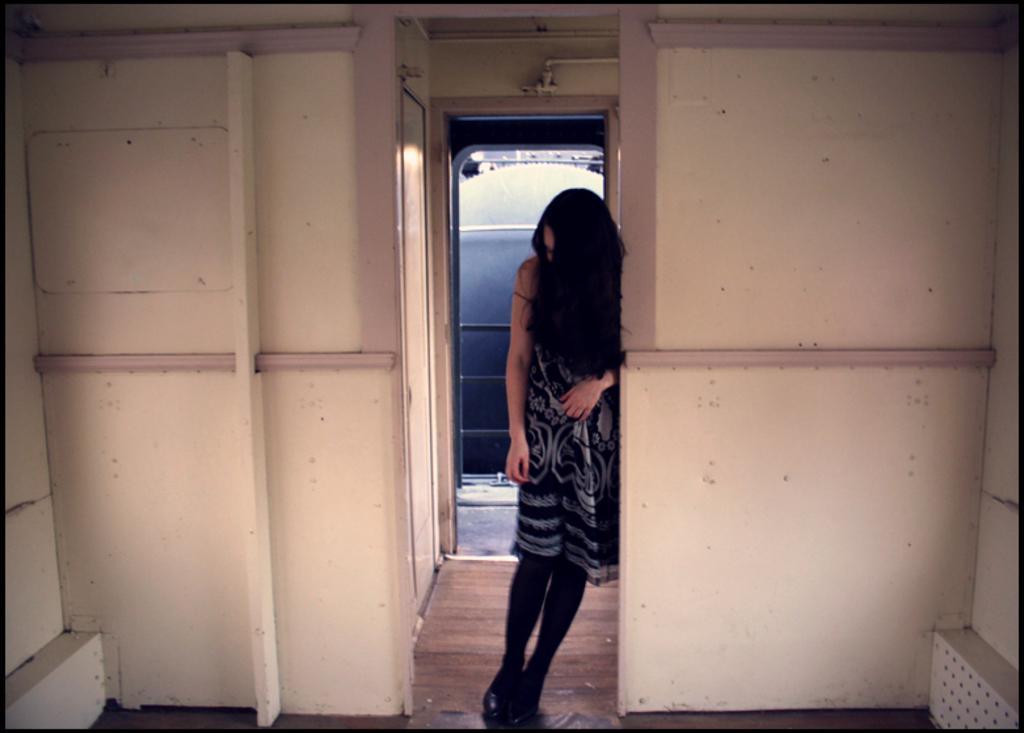In one or two sentences, can you explain what this image depicts? In the center of the image, we can see a lady standing and in the background, there is a wall and at the bottom, there is a floor. At the top, we can see pipes. 